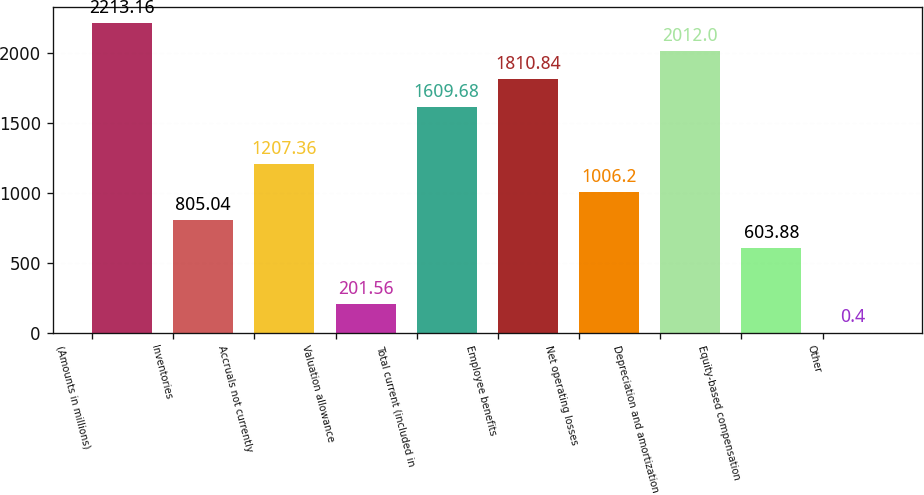Convert chart to OTSL. <chart><loc_0><loc_0><loc_500><loc_500><bar_chart><fcel>(Amounts in millions)<fcel>Inventories<fcel>Accruals not currently<fcel>Valuation allowance<fcel>Total current (included in<fcel>Employee benefits<fcel>Net operating losses<fcel>Depreciation and amortization<fcel>Equity-based compensation<fcel>Other<nl><fcel>2213.16<fcel>805.04<fcel>1207.36<fcel>201.56<fcel>1609.68<fcel>1810.84<fcel>1006.2<fcel>2012<fcel>603.88<fcel>0.4<nl></chart> 